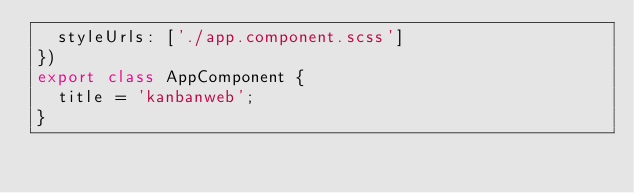<code> <loc_0><loc_0><loc_500><loc_500><_TypeScript_>  styleUrls: ['./app.component.scss']
})
export class AppComponent {
  title = 'kanbanweb';
}
</code> 